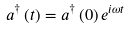Convert formula to latex. <formula><loc_0><loc_0><loc_500><loc_500>a ^ { \dagger } \left ( t \right ) = a ^ { \dagger } \left ( 0 \right ) e ^ { i \omega t }</formula> 